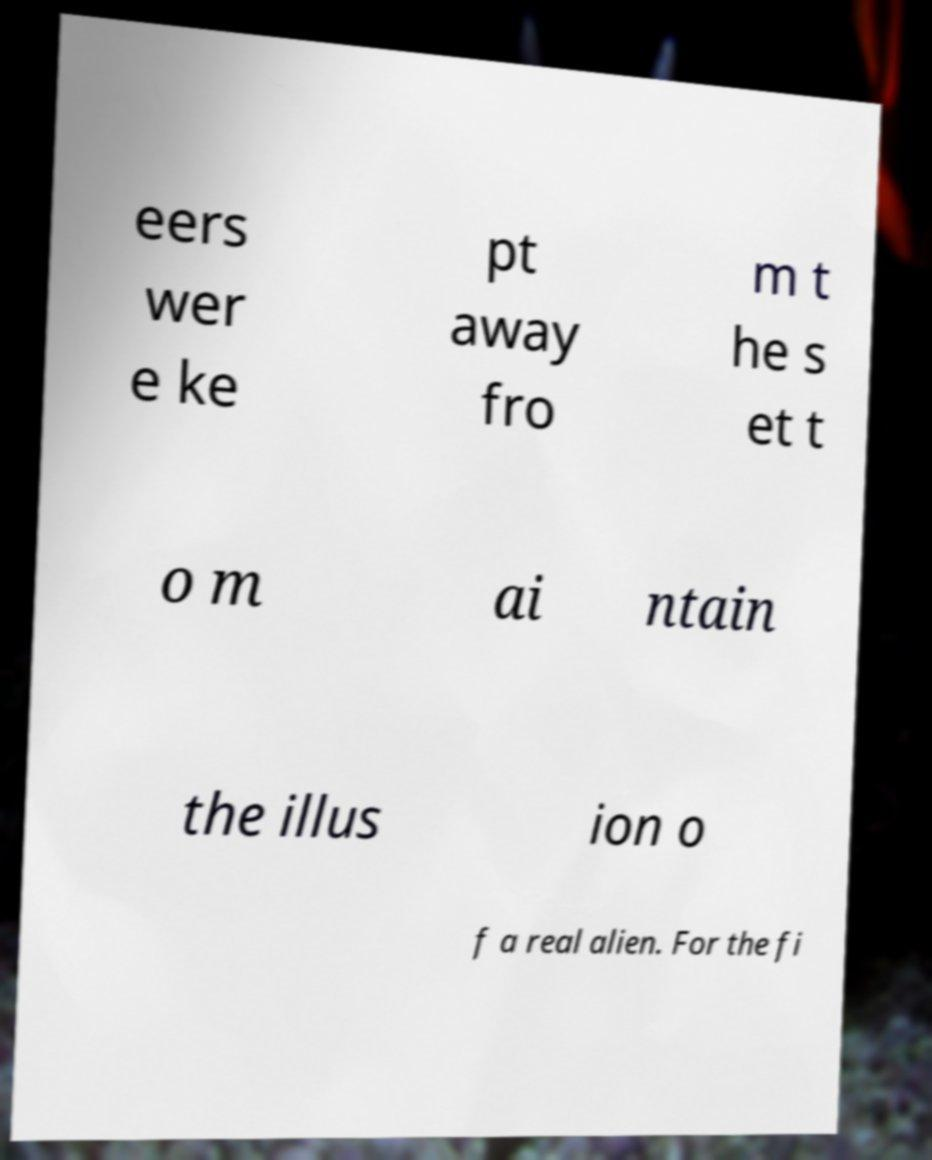There's text embedded in this image that I need extracted. Can you transcribe it verbatim? eers wer e ke pt away fro m t he s et t o m ai ntain the illus ion o f a real alien. For the fi 